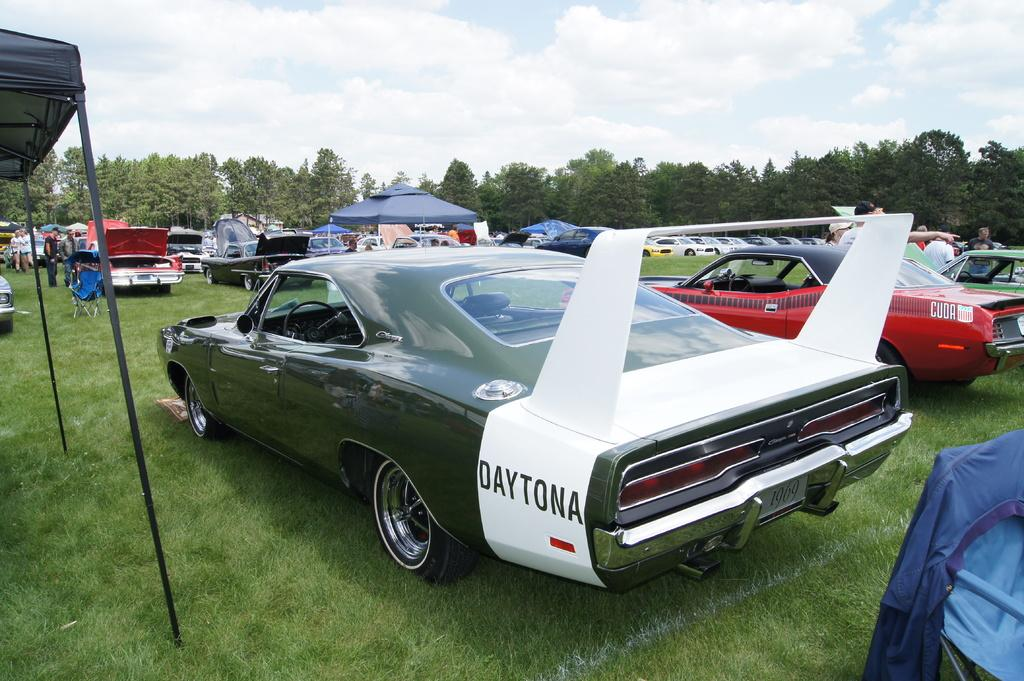What types of objects are on the ground in the image? There are vehicles on the ground in the image. What type of temporary shelter can be seen in the image? There are tents in the image. What type of furniture is present in the image? There are chairs in the image. What type of vegetation is visible in the image? There are trees and grass in the image. What part of the natural environment is visible in the image? The sky is visible in the background of the image. What is the weather like in the image? The presence of clouds in the sky suggests that it might be partly cloudy. How many passengers are sitting on the sneeze in the image? There is no sneeze present in the image, and therefore no passengers can be found on it. What type of weather condition is present in the image due to the fog? There is no fog present in the image; it features clouds in the sky. 